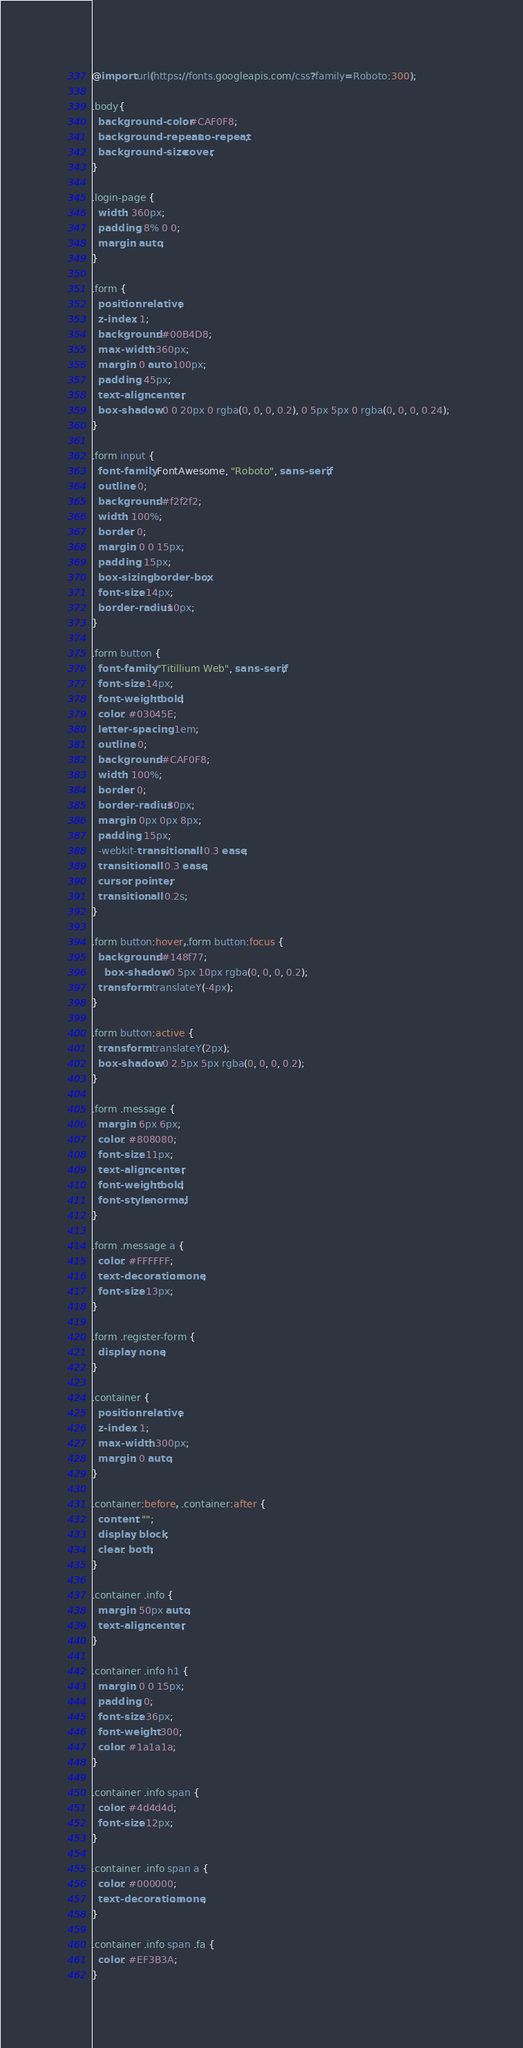<code> <loc_0><loc_0><loc_500><loc_500><_CSS_>@import url(https://fonts.googleapis.com/css?family=Roboto:300);

.body{
  background-color: #CAF0F8;
  background-repeat: no-repeat;
  background-size: cover;
}

.login-page {
  width: 360px;
  padding: 8% 0 0;
  margin: auto;
}

.form {
  position: relative;
  z-index: 1;
  background: #00B4D8;
  max-width: 360px;
  margin: 0 auto 100px;
  padding: 45px;
  text-align: center;
  box-shadow: 0 0 20px 0 rgba(0, 0, 0, 0.2), 0 5px 5px 0 rgba(0, 0, 0, 0.24);  
}

.form input {
  font-family: FontAwesome, "Roboto", sans-serif;
  outline: 0;
  background: #f2f2f2;
  width: 100%;
  border: 0;
  margin: 0 0 15px;
  padding: 15px;
  box-sizing: border-box;
  font-size: 14px;
  border-radius:10px;
}

.form button {
  font-family: "Titillium Web", sans-serif;
  font-size: 14px;
  font-weight: bold;
  color: #03045E;
  letter-spacing: .1em;
  outline: 0;
  background: #CAF0F8;
  width: 100%;
  border: 0;
  border-radius:30px;
  margin: 0px 0px 8px;
  padding: 15px;
  -webkit-transition: all 0.3 ease;
  transition: all 0.3 ease;
  cursor: pointer;
  transition: all 0.2s;
}

.form button:hover,.form button:focus {
  background: #148f77;
    box-shadow: 0 5px 10px rgba(0, 0, 0, 0.2);
  transform: translateY(-4px);
}

.form button:active {
  transform: translateY(2px);
  box-shadow: 0 2.5px 5px rgba(0, 0, 0, 0.2);
}

.form .message {
  margin: 6px 6px;
  color: #808080;
  font-size: 11px;
  text-align: center;
  font-weight: bold;
  font-style: normal;
}

.form .message a {
  color: #FFFFFF;
  text-decoration: none;
  font-size: 13px;
}

.form .register-form {
  display: none;
}

.container {
  position: relative;
  z-index: 1;
  max-width: 300px;
  margin: 0 auto;
}

.container:before, .container:after {
  content: "";
  display: block;
  clear: both;
}

.container .info {
  margin: 50px auto;
  text-align: center;
}

.container .info h1 {
  margin: 0 0 15px;
  padding: 0;
  font-size: 36px;
  font-weight: 300;
  color: #1a1a1a;
}

.container .info span {
  color: #4d4d4d;
  font-size: 12px;
}

.container .info span a {
  color: #000000;
  text-decoration: none;
}

.container .info span .fa {
  color: #EF3B3A;
}</code> 